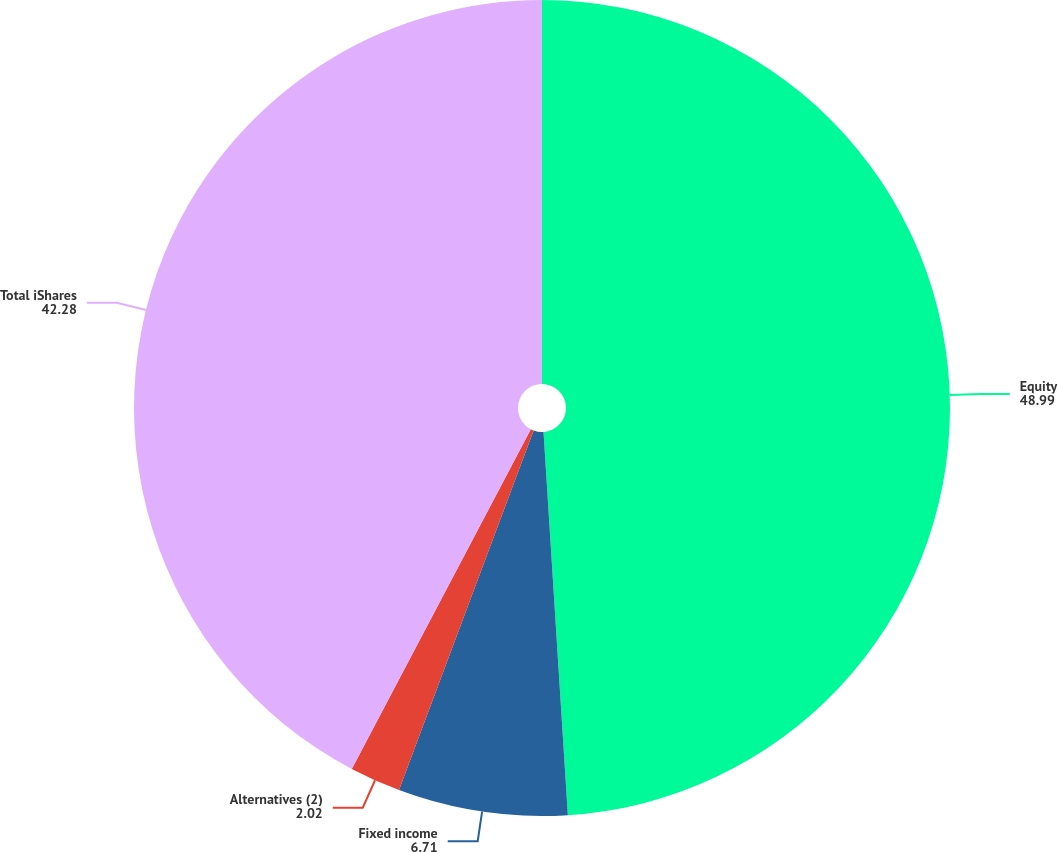Convert chart. <chart><loc_0><loc_0><loc_500><loc_500><pie_chart><fcel>Equity<fcel>Fixed income<fcel>Alternatives (2)<fcel>Total iShares<nl><fcel>48.99%<fcel>6.71%<fcel>2.02%<fcel>42.28%<nl></chart> 